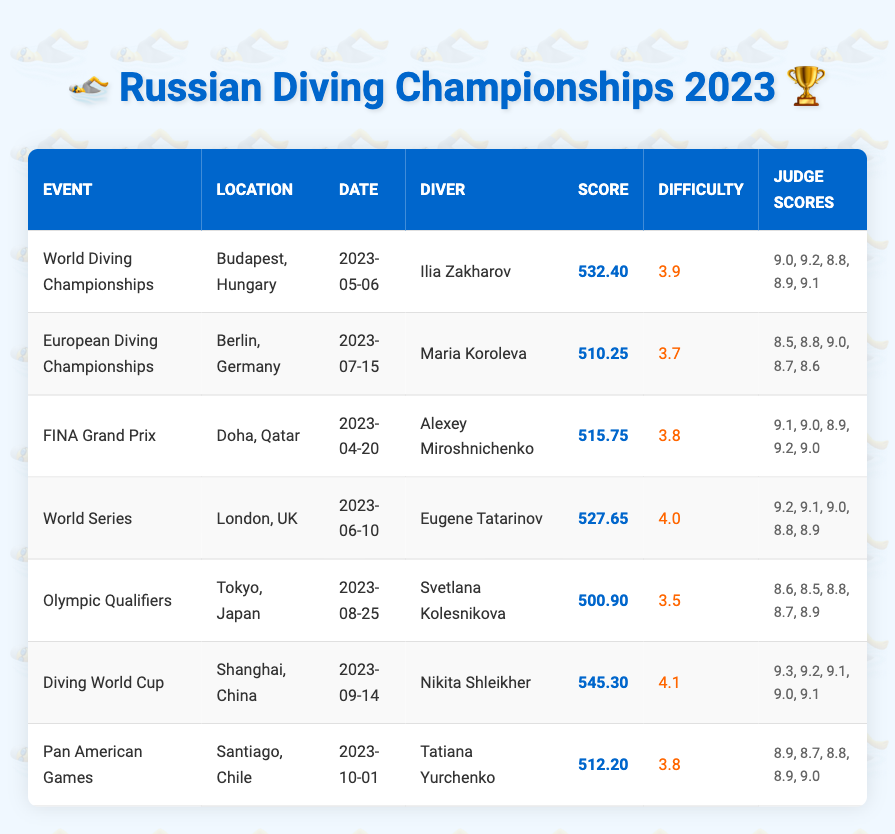What is the highest score achieved in the 2023 diving competitions? Looking through the scores listed in the table, the highest score is 545.30, achieved by Nikita Shleikher during the Diving World Cup.
Answer: 545.30 Who was the diver in the European Diving Championships? The table states that Maria Koroleva was the diver representing in the European Diving Championships held in Berlin, Germany.
Answer: Maria Koroleva Which event took place in Japan in 2023? The Olympic Qualifiers event took place in Tokyo, Japan, as indicated in the table.
Answer: Olympic Qualifiers What is the average score of the judges for Ilia Zakharov in the World Diving Championships? The scores given by judges for Ilia Zakharov are 9.0, 9.2, 8.8, 8.9, and 9.1. The average is calculated by summing these scores (9.0 + 9.2 + 8.8 + 8.9 + 9.1 = 44.0) and dividing by the number of judges (5), so the average is 44.0 / 5 = 8.80.
Answer: 8.80 Did any diver score below 510 in the listed competitions? Looking through the scores in the table, Svetlana Kolesnikova scored 500.90 in the Olympic Qualifiers, which is below 510.
Answer: Yes What is the difference in score between the highest and lowest achieved in the 2023 competitions? The highest score is 545.30 (Nikita Shleikher) and the lowest score is 500.90 (Svetlana Kolesnikova). The difference is calculated by subtracting the lowest from the highest: 545.30 - 500.90 = 44.40.
Answer: 44.40 How many events had a diving difficulty rating of 4.0 or higher? From the table, two events had a difficulty rating of 4.0 or higher: the World Series (4.0) and the Diving World Cup (4.1). So, the count is 2.
Answer: 2 Which diver had the lowest average score among the judges during their competition? The average judge score for each diver needs to be calculated. Svetlana Kolesnikova’s judges scored an average of 8.7. Other averages show Ilia Zakharov's average is 8.8, Maria Koroleva's is 8.72, and others are higher, confirming Svetlana Kolesnikova had the lowest average score among judges.
Answer: Svetlana Kolesnikova What event had the highest difficulty rating in 2023? By examining the difficulty ratings in the table, the Diving World Cup had the highest difficulty rating of 4.1.
Answer: Diving World Cup Which diver competed in both the Diving World Cup and the Olympic Qualifiers? By reviewing the table, it seems that no diver competed in both of these events as they are represented by different divers.
Answer: No diver competed in both events 